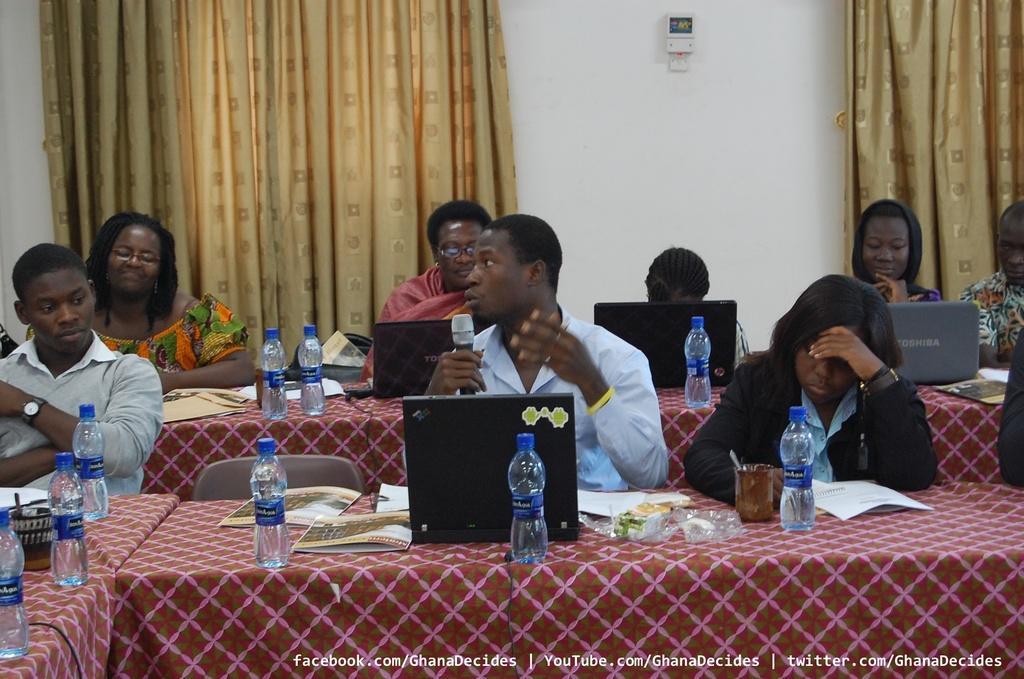Please provide a concise description of this image. Group of people sitting on the chairs and this person holding microphone and talking. We can see laptops,bottles,books,covers on the tables. On the background we can see wall,curtains. 